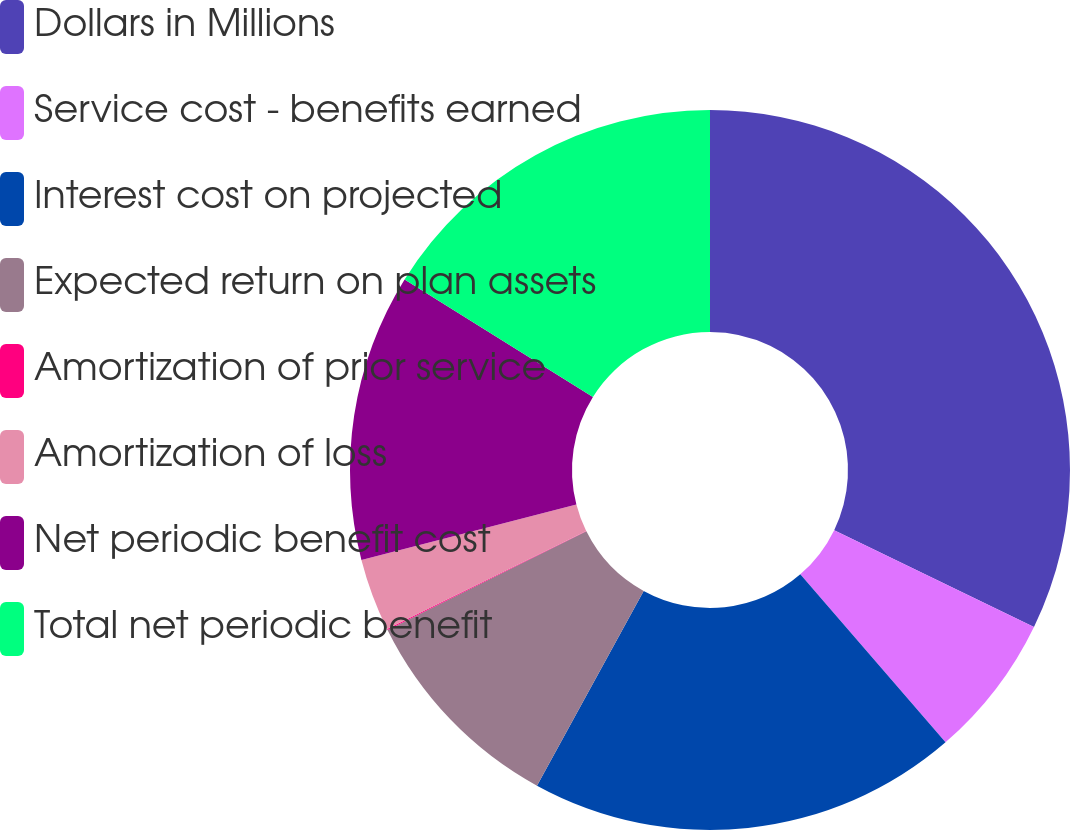<chart> <loc_0><loc_0><loc_500><loc_500><pie_chart><fcel>Dollars in Millions<fcel>Service cost - benefits earned<fcel>Interest cost on projected<fcel>Expected return on plan assets<fcel>Amortization of prior service<fcel>Amortization of loss<fcel>Net periodic benefit cost<fcel>Total net periodic benefit<nl><fcel>32.18%<fcel>6.47%<fcel>19.33%<fcel>9.69%<fcel>0.05%<fcel>3.26%<fcel>12.9%<fcel>16.12%<nl></chart> 